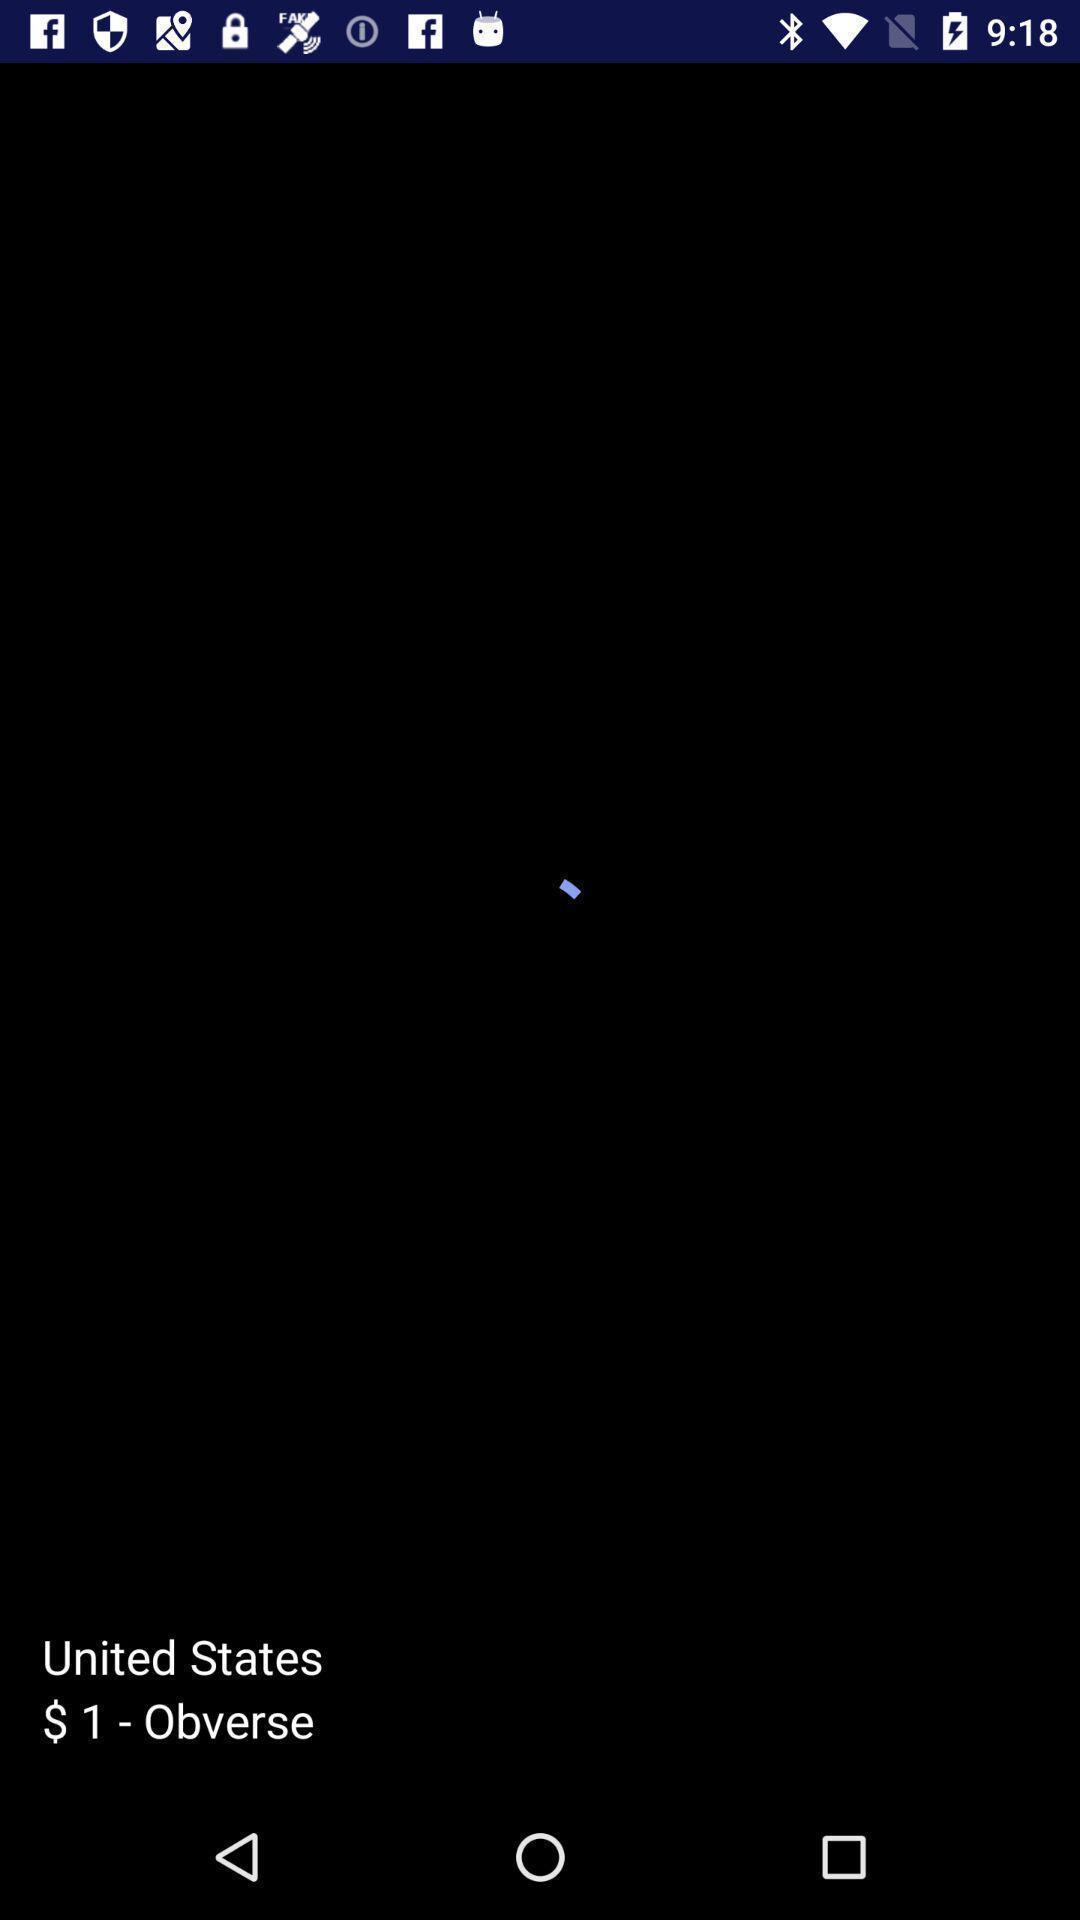Describe the visual elements of this screenshot. Page shows the united states dollar on currency app. 